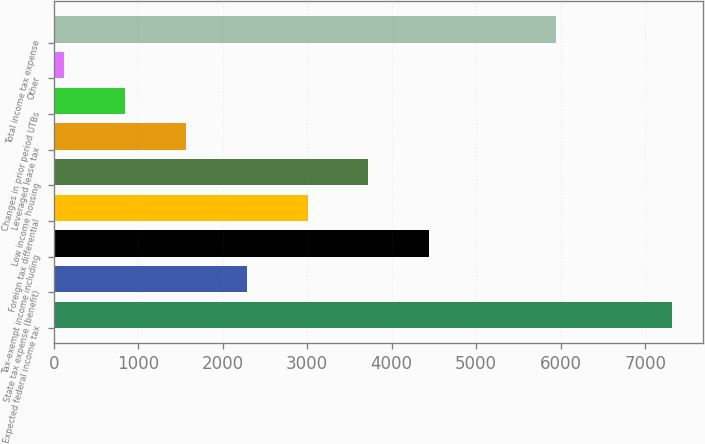<chart> <loc_0><loc_0><loc_500><loc_500><bar_chart><fcel>Expected federal income tax<fcel>State tax expense (benefit)<fcel>Tax-exempt income including<fcel>Foreign tax differential<fcel>Low income housing<fcel>Leveraged lease tax<fcel>Changes in prior period UTBs<fcel>Other<fcel>Total income tax expense<nl><fcel>7323<fcel>2283.7<fcel>4443.4<fcel>3003.6<fcel>3723.5<fcel>1563.8<fcel>843.9<fcel>124<fcel>5942<nl></chart> 